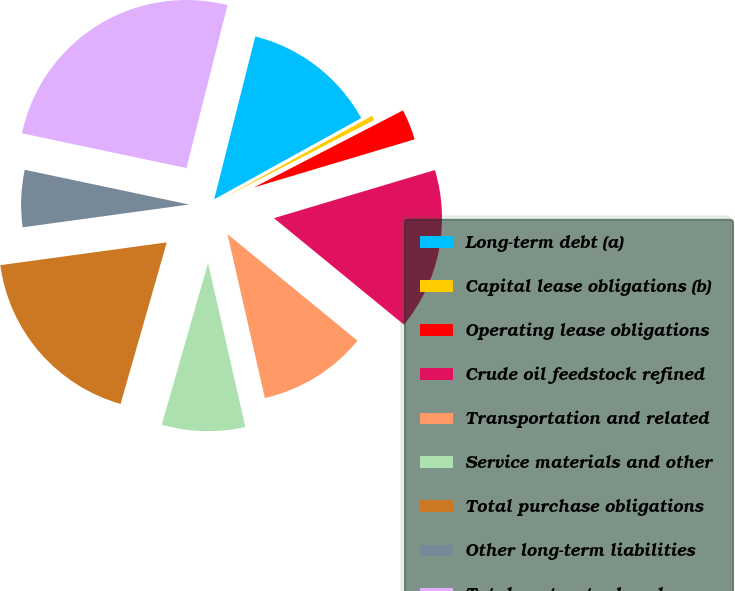Convert chart to OTSL. <chart><loc_0><loc_0><loc_500><loc_500><pie_chart><fcel>Long-term debt (a)<fcel>Capital lease obligations (b)<fcel>Operating lease obligations<fcel>Crude oil feedstock refined<fcel>Transportation and related<fcel>Service materials and other<fcel>Total purchase obligations<fcel>Other long-term liabilities<fcel>Total contractual cash<nl><fcel>13.03%<fcel>0.45%<fcel>2.96%<fcel>15.55%<fcel>10.51%<fcel>8.0%<fcel>18.4%<fcel>5.48%<fcel>25.62%<nl></chart> 